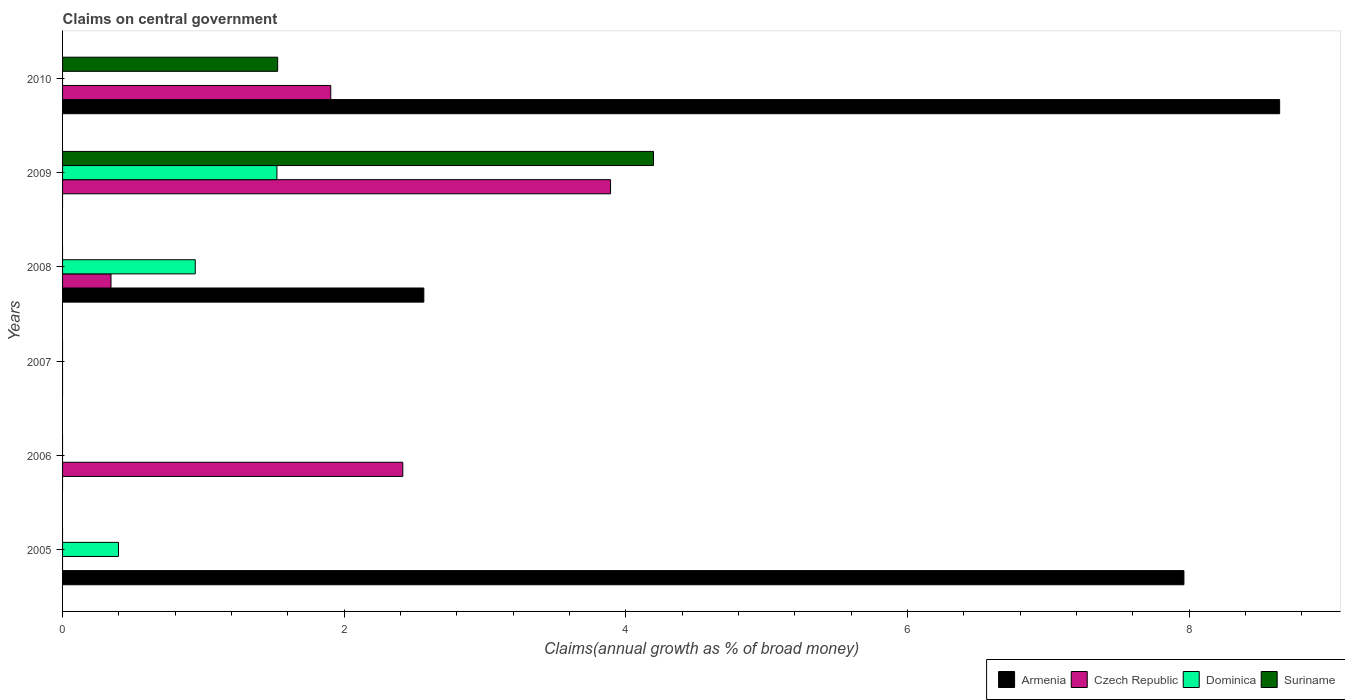How many different coloured bars are there?
Give a very brief answer. 4. Are the number of bars per tick equal to the number of legend labels?
Provide a succinct answer. No. Are the number of bars on each tick of the Y-axis equal?
Your answer should be very brief. No. How many bars are there on the 3rd tick from the top?
Offer a very short reply. 3. How many bars are there on the 2nd tick from the bottom?
Keep it short and to the point. 1. What is the label of the 5th group of bars from the top?
Your answer should be very brief. 2006. What is the percentage of broad money claimed on centeral government in Armenia in 2006?
Offer a terse response. 0. Across all years, what is the maximum percentage of broad money claimed on centeral government in Dominica?
Your answer should be very brief. 1.52. Across all years, what is the minimum percentage of broad money claimed on centeral government in Czech Republic?
Make the answer very short. 0. In which year was the percentage of broad money claimed on centeral government in Suriname maximum?
Make the answer very short. 2009. What is the total percentage of broad money claimed on centeral government in Dominica in the graph?
Your answer should be compact. 2.86. What is the difference between the percentage of broad money claimed on centeral government in Czech Republic in 2008 and that in 2009?
Make the answer very short. -3.55. What is the difference between the percentage of broad money claimed on centeral government in Armenia in 2010 and the percentage of broad money claimed on centeral government in Dominica in 2006?
Your answer should be compact. 8.64. What is the average percentage of broad money claimed on centeral government in Dominica per year?
Make the answer very short. 0.48. In the year 2009, what is the difference between the percentage of broad money claimed on centeral government in Suriname and percentage of broad money claimed on centeral government in Dominica?
Keep it short and to the point. 2.67. In how many years, is the percentage of broad money claimed on centeral government in Czech Republic greater than 0.4 %?
Your answer should be very brief. 3. What is the difference between the highest and the second highest percentage of broad money claimed on centeral government in Armenia?
Ensure brevity in your answer.  0.68. What is the difference between the highest and the lowest percentage of broad money claimed on centeral government in Armenia?
Your answer should be compact. 8.64. Is it the case that in every year, the sum of the percentage of broad money claimed on centeral government in Armenia and percentage of broad money claimed on centeral government in Dominica is greater than the sum of percentage of broad money claimed on centeral government in Suriname and percentage of broad money claimed on centeral government in Czech Republic?
Your answer should be very brief. No. Is it the case that in every year, the sum of the percentage of broad money claimed on centeral government in Czech Republic and percentage of broad money claimed on centeral government in Suriname is greater than the percentage of broad money claimed on centeral government in Dominica?
Make the answer very short. No. What is the difference between two consecutive major ticks on the X-axis?
Give a very brief answer. 2. Are the values on the major ticks of X-axis written in scientific E-notation?
Your answer should be compact. No. Does the graph contain any zero values?
Make the answer very short. Yes. Where does the legend appear in the graph?
Your answer should be compact. Bottom right. What is the title of the graph?
Offer a very short reply. Claims on central government. What is the label or title of the X-axis?
Your answer should be compact. Claims(annual growth as % of broad money). What is the label or title of the Y-axis?
Offer a terse response. Years. What is the Claims(annual growth as % of broad money) in Armenia in 2005?
Your response must be concise. 7.96. What is the Claims(annual growth as % of broad money) of Czech Republic in 2005?
Provide a short and direct response. 0. What is the Claims(annual growth as % of broad money) in Dominica in 2005?
Provide a succinct answer. 0.4. What is the Claims(annual growth as % of broad money) in Suriname in 2005?
Your response must be concise. 0. What is the Claims(annual growth as % of broad money) in Czech Republic in 2006?
Offer a terse response. 2.42. What is the Claims(annual growth as % of broad money) of Dominica in 2006?
Offer a very short reply. 0. What is the Claims(annual growth as % of broad money) in Suriname in 2006?
Make the answer very short. 0. What is the Claims(annual growth as % of broad money) of Armenia in 2007?
Your response must be concise. 0. What is the Claims(annual growth as % of broad money) in Czech Republic in 2007?
Give a very brief answer. 0. What is the Claims(annual growth as % of broad money) of Dominica in 2007?
Your response must be concise. 0. What is the Claims(annual growth as % of broad money) in Suriname in 2007?
Provide a short and direct response. 0. What is the Claims(annual growth as % of broad money) of Armenia in 2008?
Your answer should be very brief. 2.57. What is the Claims(annual growth as % of broad money) of Czech Republic in 2008?
Provide a short and direct response. 0.34. What is the Claims(annual growth as % of broad money) of Dominica in 2008?
Offer a terse response. 0.94. What is the Claims(annual growth as % of broad money) in Armenia in 2009?
Your answer should be compact. 0. What is the Claims(annual growth as % of broad money) in Czech Republic in 2009?
Offer a very short reply. 3.89. What is the Claims(annual growth as % of broad money) in Dominica in 2009?
Offer a very short reply. 1.52. What is the Claims(annual growth as % of broad money) of Suriname in 2009?
Keep it short and to the point. 4.2. What is the Claims(annual growth as % of broad money) of Armenia in 2010?
Give a very brief answer. 8.64. What is the Claims(annual growth as % of broad money) of Czech Republic in 2010?
Your answer should be compact. 1.9. What is the Claims(annual growth as % of broad money) of Suriname in 2010?
Your answer should be compact. 1.53. Across all years, what is the maximum Claims(annual growth as % of broad money) in Armenia?
Provide a short and direct response. 8.64. Across all years, what is the maximum Claims(annual growth as % of broad money) in Czech Republic?
Provide a succinct answer. 3.89. Across all years, what is the maximum Claims(annual growth as % of broad money) in Dominica?
Your answer should be very brief. 1.52. Across all years, what is the maximum Claims(annual growth as % of broad money) of Suriname?
Ensure brevity in your answer.  4.2. Across all years, what is the minimum Claims(annual growth as % of broad money) in Armenia?
Provide a succinct answer. 0. Across all years, what is the minimum Claims(annual growth as % of broad money) of Czech Republic?
Offer a terse response. 0. What is the total Claims(annual growth as % of broad money) of Armenia in the graph?
Offer a very short reply. 19.17. What is the total Claims(annual growth as % of broad money) of Czech Republic in the graph?
Your response must be concise. 8.55. What is the total Claims(annual growth as % of broad money) in Dominica in the graph?
Your answer should be very brief. 2.86. What is the total Claims(annual growth as % of broad money) of Suriname in the graph?
Offer a very short reply. 5.72. What is the difference between the Claims(annual growth as % of broad money) in Armenia in 2005 and that in 2008?
Ensure brevity in your answer.  5.4. What is the difference between the Claims(annual growth as % of broad money) of Dominica in 2005 and that in 2008?
Offer a terse response. -0.55. What is the difference between the Claims(annual growth as % of broad money) in Dominica in 2005 and that in 2009?
Provide a succinct answer. -1.12. What is the difference between the Claims(annual growth as % of broad money) of Armenia in 2005 and that in 2010?
Your answer should be compact. -0.68. What is the difference between the Claims(annual growth as % of broad money) in Czech Republic in 2006 and that in 2008?
Ensure brevity in your answer.  2.07. What is the difference between the Claims(annual growth as % of broad money) of Czech Republic in 2006 and that in 2009?
Your answer should be compact. -1.48. What is the difference between the Claims(annual growth as % of broad money) of Czech Republic in 2006 and that in 2010?
Provide a short and direct response. 0.51. What is the difference between the Claims(annual growth as % of broad money) in Czech Republic in 2008 and that in 2009?
Keep it short and to the point. -3.55. What is the difference between the Claims(annual growth as % of broad money) of Dominica in 2008 and that in 2009?
Your answer should be compact. -0.58. What is the difference between the Claims(annual growth as % of broad money) of Armenia in 2008 and that in 2010?
Ensure brevity in your answer.  -6.08. What is the difference between the Claims(annual growth as % of broad money) of Czech Republic in 2008 and that in 2010?
Provide a short and direct response. -1.56. What is the difference between the Claims(annual growth as % of broad money) in Czech Republic in 2009 and that in 2010?
Offer a very short reply. 1.99. What is the difference between the Claims(annual growth as % of broad money) of Suriname in 2009 and that in 2010?
Offer a very short reply. 2.67. What is the difference between the Claims(annual growth as % of broad money) of Armenia in 2005 and the Claims(annual growth as % of broad money) of Czech Republic in 2006?
Your response must be concise. 5.55. What is the difference between the Claims(annual growth as % of broad money) of Armenia in 2005 and the Claims(annual growth as % of broad money) of Czech Republic in 2008?
Provide a short and direct response. 7.62. What is the difference between the Claims(annual growth as % of broad money) of Armenia in 2005 and the Claims(annual growth as % of broad money) of Dominica in 2008?
Your answer should be very brief. 7.02. What is the difference between the Claims(annual growth as % of broad money) of Armenia in 2005 and the Claims(annual growth as % of broad money) of Czech Republic in 2009?
Provide a succinct answer. 4.07. What is the difference between the Claims(annual growth as % of broad money) in Armenia in 2005 and the Claims(annual growth as % of broad money) in Dominica in 2009?
Your answer should be compact. 6.44. What is the difference between the Claims(annual growth as % of broad money) of Armenia in 2005 and the Claims(annual growth as % of broad money) of Suriname in 2009?
Your response must be concise. 3.77. What is the difference between the Claims(annual growth as % of broad money) of Dominica in 2005 and the Claims(annual growth as % of broad money) of Suriname in 2009?
Provide a short and direct response. -3.8. What is the difference between the Claims(annual growth as % of broad money) in Armenia in 2005 and the Claims(annual growth as % of broad money) in Czech Republic in 2010?
Offer a very short reply. 6.06. What is the difference between the Claims(annual growth as % of broad money) in Armenia in 2005 and the Claims(annual growth as % of broad money) in Suriname in 2010?
Offer a very short reply. 6.43. What is the difference between the Claims(annual growth as % of broad money) of Dominica in 2005 and the Claims(annual growth as % of broad money) of Suriname in 2010?
Ensure brevity in your answer.  -1.13. What is the difference between the Claims(annual growth as % of broad money) of Czech Republic in 2006 and the Claims(annual growth as % of broad money) of Dominica in 2008?
Ensure brevity in your answer.  1.47. What is the difference between the Claims(annual growth as % of broad money) in Czech Republic in 2006 and the Claims(annual growth as % of broad money) in Dominica in 2009?
Provide a succinct answer. 0.89. What is the difference between the Claims(annual growth as % of broad money) of Czech Republic in 2006 and the Claims(annual growth as % of broad money) of Suriname in 2009?
Your response must be concise. -1.78. What is the difference between the Claims(annual growth as % of broad money) of Czech Republic in 2006 and the Claims(annual growth as % of broad money) of Suriname in 2010?
Provide a succinct answer. 0.89. What is the difference between the Claims(annual growth as % of broad money) in Armenia in 2008 and the Claims(annual growth as % of broad money) in Czech Republic in 2009?
Your answer should be very brief. -1.33. What is the difference between the Claims(annual growth as % of broad money) in Armenia in 2008 and the Claims(annual growth as % of broad money) in Dominica in 2009?
Your answer should be compact. 1.04. What is the difference between the Claims(annual growth as % of broad money) in Armenia in 2008 and the Claims(annual growth as % of broad money) in Suriname in 2009?
Offer a very short reply. -1.63. What is the difference between the Claims(annual growth as % of broad money) of Czech Republic in 2008 and the Claims(annual growth as % of broad money) of Dominica in 2009?
Your response must be concise. -1.18. What is the difference between the Claims(annual growth as % of broad money) of Czech Republic in 2008 and the Claims(annual growth as % of broad money) of Suriname in 2009?
Give a very brief answer. -3.85. What is the difference between the Claims(annual growth as % of broad money) in Dominica in 2008 and the Claims(annual growth as % of broad money) in Suriname in 2009?
Offer a very short reply. -3.25. What is the difference between the Claims(annual growth as % of broad money) in Armenia in 2008 and the Claims(annual growth as % of broad money) in Czech Republic in 2010?
Offer a very short reply. 0.66. What is the difference between the Claims(annual growth as % of broad money) of Armenia in 2008 and the Claims(annual growth as % of broad money) of Suriname in 2010?
Keep it short and to the point. 1.04. What is the difference between the Claims(annual growth as % of broad money) in Czech Republic in 2008 and the Claims(annual growth as % of broad money) in Suriname in 2010?
Provide a succinct answer. -1.18. What is the difference between the Claims(annual growth as % of broad money) in Dominica in 2008 and the Claims(annual growth as % of broad money) in Suriname in 2010?
Your response must be concise. -0.58. What is the difference between the Claims(annual growth as % of broad money) of Czech Republic in 2009 and the Claims(annual growth as % of broad money) of Suriname in 2010?
Offer a terse response. 2.36. What is the difference between the Claims(annual growth as % of broad money) in Dominica in 2009 and the Claims(annual growth as % of broad money) in Suriname in 2010?
Your answer should be compact. -0.01. What is the average Claims(annual growth as % of broad money) in Armenia per year?
Offer a terse response. 3.19. What is the average Claims(annual growth as % of broad money) of Czech Republic per year?
Offer a terse response. 1.43. What is the average Claims(annual growth as % of broad money) in Dominica per year?
Ensure brevity in your answer.  0.48. What is the average Claims(annual growth as % of broad money) of Suriname per year?
Ensure brevity in your answer.  0.95. In the year 2005, what is the difference between the Claims(annual growth as % of broad money) of Armenia and Claims(annual growth as % of broad money) of Dominica?
Ensure brevity in your answer.  7.57. In the year 2008, what is the difference between the Claims(annual growth as % of broad money) in Armenia and Claims(annual growth as % of broad money) in Czech Republic?
Give a very brief answer. 2.22. In the year 2008, what is the difference between the Claims(annual growth as % of broad money) of Armenia and Claims(annual growth as % of broad money) of Dominica?
Your answer should be very brief. 1.62. In the year 2008, what is the difference between the Claims(annual growth as % of broad money) of Czech Republic and Claims(annual growth as % of broad money) of Dominica?
Offer a very short reply. -0.6. In the year 2009, what is the difference between the Claims(annual growth as % of broad money) of Czech Republic and Claims(annual growth as % of broad money) of Dominica?
Give a very brief answer. 2.37. In the year 2009, what is the difference between the Claims(annual growth as % of broad money) in Czech Republic and Claims(annual growth as % of broad money) in Suriname?
Offer a very short reply. -0.3. In the year 2009, what is the difference between the Claims(annual growth as % of broad money) of Dominica and Claims(annual growth as % of broad money) of Suriname?
Offer a terse response. -2.67. In the year 2010, what is the difference between the Claims(annual growth as % of broad money) of Armenia and Claims(annual growth as % of broad money) of Czech Republic?
Provide a short and direct response. 6.74. In the year 2010, what is the difference between the Claims(annual growth as % of broad money) in Armenia and Claims(annual growth as % of broad money) in Suriname?
Your answer should be compact. 7.11. In the year 2010, what is the difference between the Claims(annual growth as % of broad money) of Czech Republic and Claims(annual growth as % of broad money) of Suriname?
Your answer should be compact. 0.38. What is the ratio of the Claims(annual growth as % of broad money) of Armenia in 2005 to that in 2008?
Provide a short and direct response. 3.1. What is the ratio of the Claims(annual growth as % of broad money) in Dominica in 2005 to that in 2008?
Keep it short and to the point. 0.42. What is the ratio of the Claims(annual growth as % of broad money) of Dominica in 2005 to that in 2009?
Make the answer very short. 0.26. What is the ratio of the Claims(annual growth as % of broad money) in Armenia in 2005 to that in 2010?
Keep it short and to the point. 0.92. What is the ratio of the Claims(annual growth as % of broad money) in Czech Republic in 2006 to that in 2008?
Your response must be concise. 7.02. What is the ratio of the Claims(annual growth as % of broad money) of Czech Republic in 2006 to that in 2009?
Offer a terse response. 0.62. What is the ratio of the Claims(annual growth as % of broad money) of Czech Republic in 2006 to that in 2010?
Make the answer very short. 1.27. What is the ratio of the Claims(annual growth as % of broad money) of Czech Republic in 2008 to that in 2009?
Provide a short and direct response. 0.09. What is the ratio of the Claims(annual growth as % of broad money) in Dominica in 2008 to that in 2009?
Your answer should be compact. 0.62. What is the ratio of the Claims(annual growth as % of broad money) of Armenia in 2008 to that in 2010?
Keep it short and to the point. 0.3. What is the ratio of the Claims(annual growth as % of broad money) in Czech Republic in 2008 to that in 2010?
Your answer should be very brief. 0.18. What is the ratio of the Claims(annual growth as % of broad money) of Czech Republic in 2009 to that in 2010?
Give a very brief answer. 2.04. What is the ratio of the Claims(annual growth as % of broad money) in Suriname in 2009 to that in 2010?
Offer a terse response. 2.75. What is the difference between the highest and the second highest Claims(annual growth as % of broad money) of Armenia?
Your response must be concise. 0.68. What is the difference between the highest and the second highest Claims(annual growth as % of broad money) in Czech Republic?
Your answer should be very brief. 1.48. What is the difference between the highest and the second highest Claims(annual growth as % of broad money) of Dominica?
Provide a succinct answer. 0.58. What is the difference between the highest and the lowest Claims(annual growth as % of broad money) of Armenia?
Your answer should be very brief. 8.64. What is the difference between the highest and the lowest Claims(annual growth as % of broad money) of Czech Republic?
Your response must be concise. 3.89. What is the difference between the highest and the lowest Claims(annual growth as % of broad money) of Dominica?
Keep it short and to the point. 1.52. What is the difference between the highest and the lowest Claims(annual growth as % of broad money) of Suriname?
Provide a succinct answer. 4.2. 